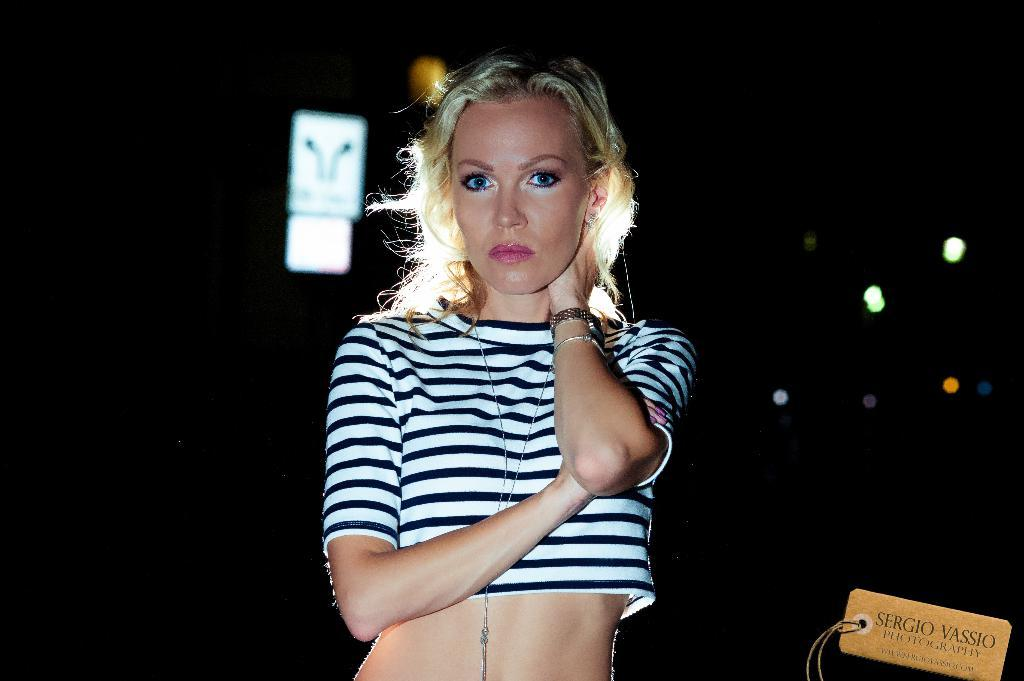What is the main subject of the image? There is a woman standing in the image. Can you describe the background of the image? The background of the image is dark. Is there any additional information about the image itself? Yes, there is a watermark on the image. What type of governor can be seen in the image? There is no governor present in the image; it features a woman standing in a dark background. How many crows are visible in the image? There are no crows present in the image. 